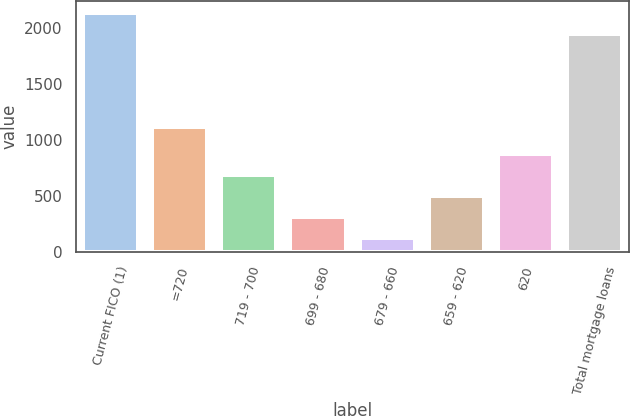Convert chart. <chart><loc_0><loc_0><loc_500><loc_500><bar_chart><fcel>Current FICO (1)<fcel>=720<fcel>719 - 700<fcel>699 - 680<fcel>679 - 660<fcel>659 - 620<fcel>620<fcel>Total mortgage loans<nl><fcel>2139.5<fcel>1121<fcel>689.5<fcel>310.5<fcel>121<fcel>500<fcel>879<fcel>1950<nl></chart> 